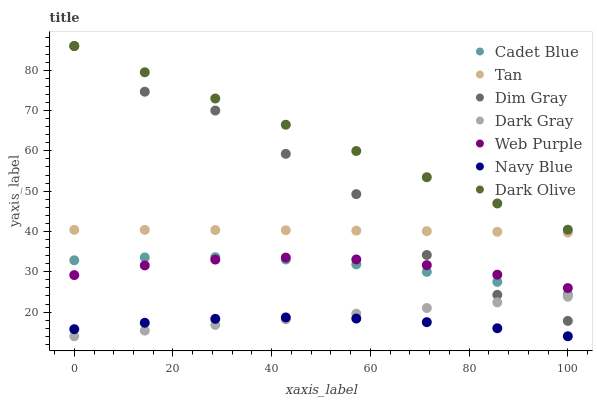Does Navy Blue have the minimum area under the curve?
Answer yes or no. Yes. Does Dark Olive have the maximum area under the curve?
Answer yes or no. Yes. Does Dark Olive have the minimum area under the curve?
Answer yes or no. No. Does Navy Blue have the maximum area under the curve?
Answer yes or no. No. Is Dark Gray the smoothest?
Answer yes or no. Yes. Is Dim Gray the roughest?
Answer yes or no. Yes. Is Navy Blue the smoothest?
Answer yes or no. No. Is Navy Blue the roughest?
Answer yes or no. No. Does Navy Blue have the lowest value?
Answer yes or no. Yes. Does Dark Olive have the lowest value?
Answer yes or no. No. Does Dim Gray have the highest value?
Answer yes or no. Yes. Does Navy Blue have the highest value?
Answer yes or no. No. Is Dark Gray less than Dark Olive?
Answer yes or no. Yes. Is Web Purple greater than Dark Gray?
Answer yes or no. Yes. Does Dark Olive intersect Dim Gray?
Answer yes or no. Yes. Is Dark Olive less than Dim Gray?
Answer yes or no. No. Is Dark Olive greater than Dim Gray?
Answer yes or no. No. Does Dark Gray intersect Dark Olive?
Answer yes or no. No. 